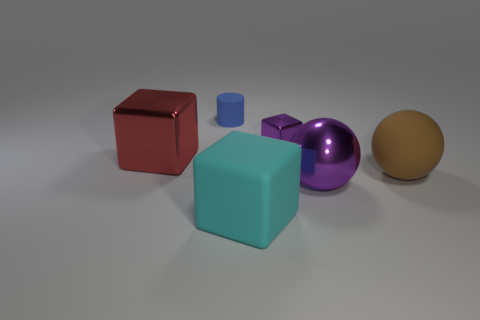There is a thing that is the same color as the large metal ball; what is its shape?
Provide a short and direct response. Cube. Is the number of large rubber things that are left of the cyan block the same as the number of cyan matte objects?
Your response must be concise. No. What is the size of the brown thing that is right of the big red object?
Your answer should be very brief. Large. How many large things are matte things or purple shiny balls?
Offer a terse response. 3. There is a large rubber object that is the same shape as the big purple metallic object; what is its color?
Provide a short and direct response. Brown. Do the blue rubber thing and the brown ball have the same size?
Your answer should be compact. No. How many objects are either matte balls or cubes that are left of the blue matte cylinder?
Your answer should be very brief. 2. The shiny object that is in front of the big red metal cube that is in front of the small blue matte cylinder is what color?
Offer a very short reply. Purple. Do the big cube that is to the right of the red shiny block and the tiny rubber object have the same color?
Provide a short and direct response. No. What material is the cube in front of the red metallic thing?
Offer a very short reply. Rubber. 